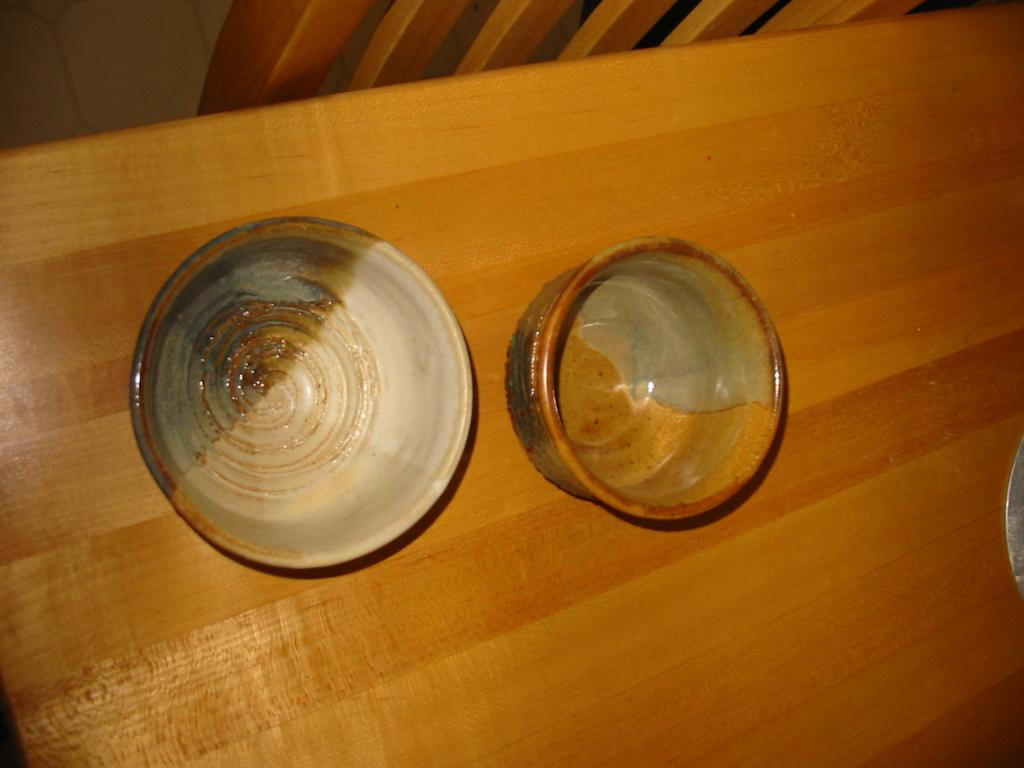What type of dishware is present in the image? There are two porcelain bowls in the image. Where are the bowls located? The bowls are on a dining table. What disease is being treated in the image? There is no indication of a disease or treatment in the image; it only features two porcelain bowls on a dining table. 